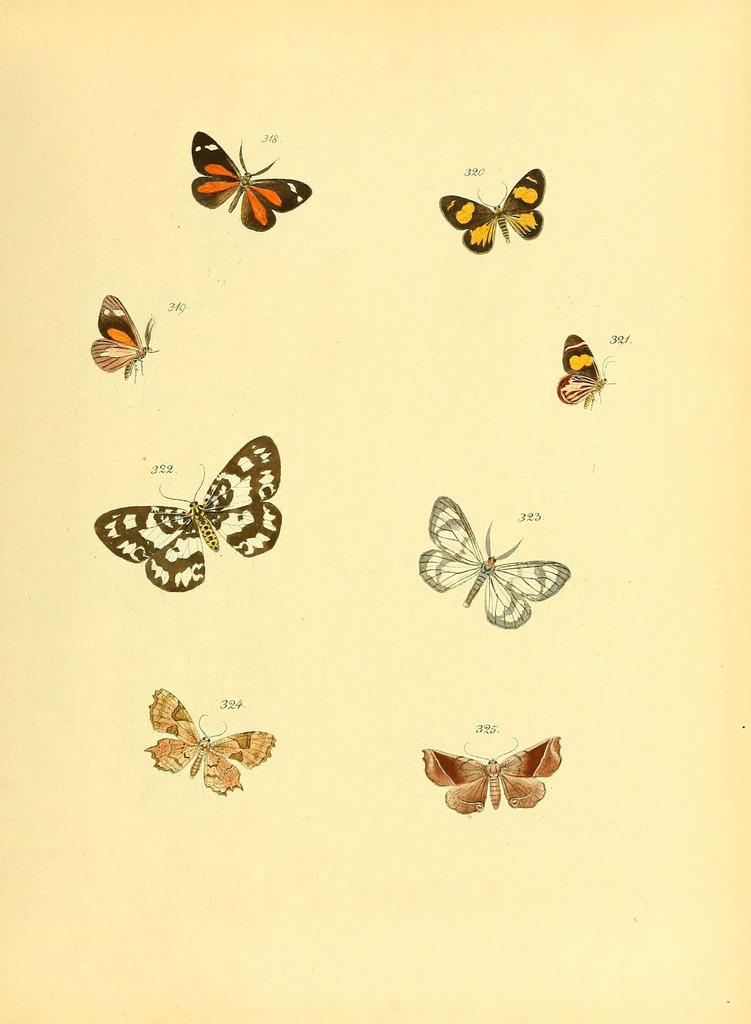What material is the main component of the image? The image consists of paper. What is depicted on the paper? There are pictures of butterflies on the paper. Where is the sofa located in the image? There is no sofa present in the image; it consists of paper with pictures of butterflies. What type of yam is being served on the tray in the image? There is no tray or yam present in the image; it consists of paper with pictures of butterflies. 